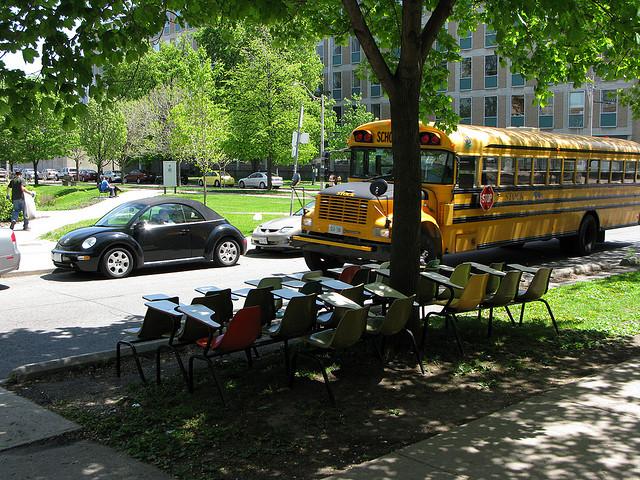What objects are surrounding the tree?
Answer briefly. Desks. How many chairs are there?
Quick response, please. 16. Where is this vehicle going?
Give a very brief answer. School. 